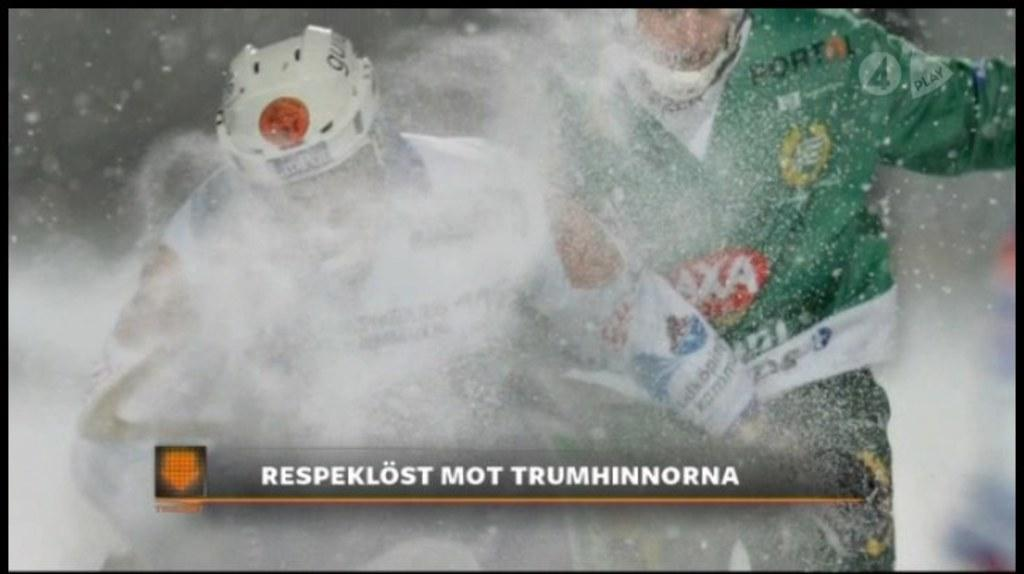How many people are in the image? There are two persons in the image. What are the persons wearing? The persons are wearing jackets and helmets. What activity are the persons engaged in? The persons are sporting on the snow. Can you describe the background of the image? The background of the image is blurry. Are there any giants visible in the image? No, there are no giants present in the image. Can you see a donkey in the background of the image? No, there is no donkey visible in the image. 